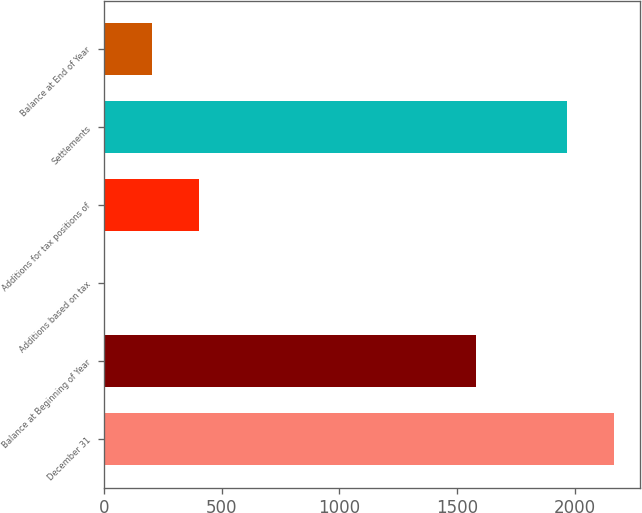Convert chart to OTSL. <chart><loc_0><loc_0><loc_500><loc_500><bar_chart><fcel>December 31<fcel>Balance at Beginning of Year<fcel>Additions based on tax<fcel>Additions for tax positions of<fcel>Settlements<fcel>Balance at End of Year<nl><fcel>2169.1<fcel>1581<fcel>1.97<fcel>404.17<fcel>1968<fcel>203.07<nl></chart> 